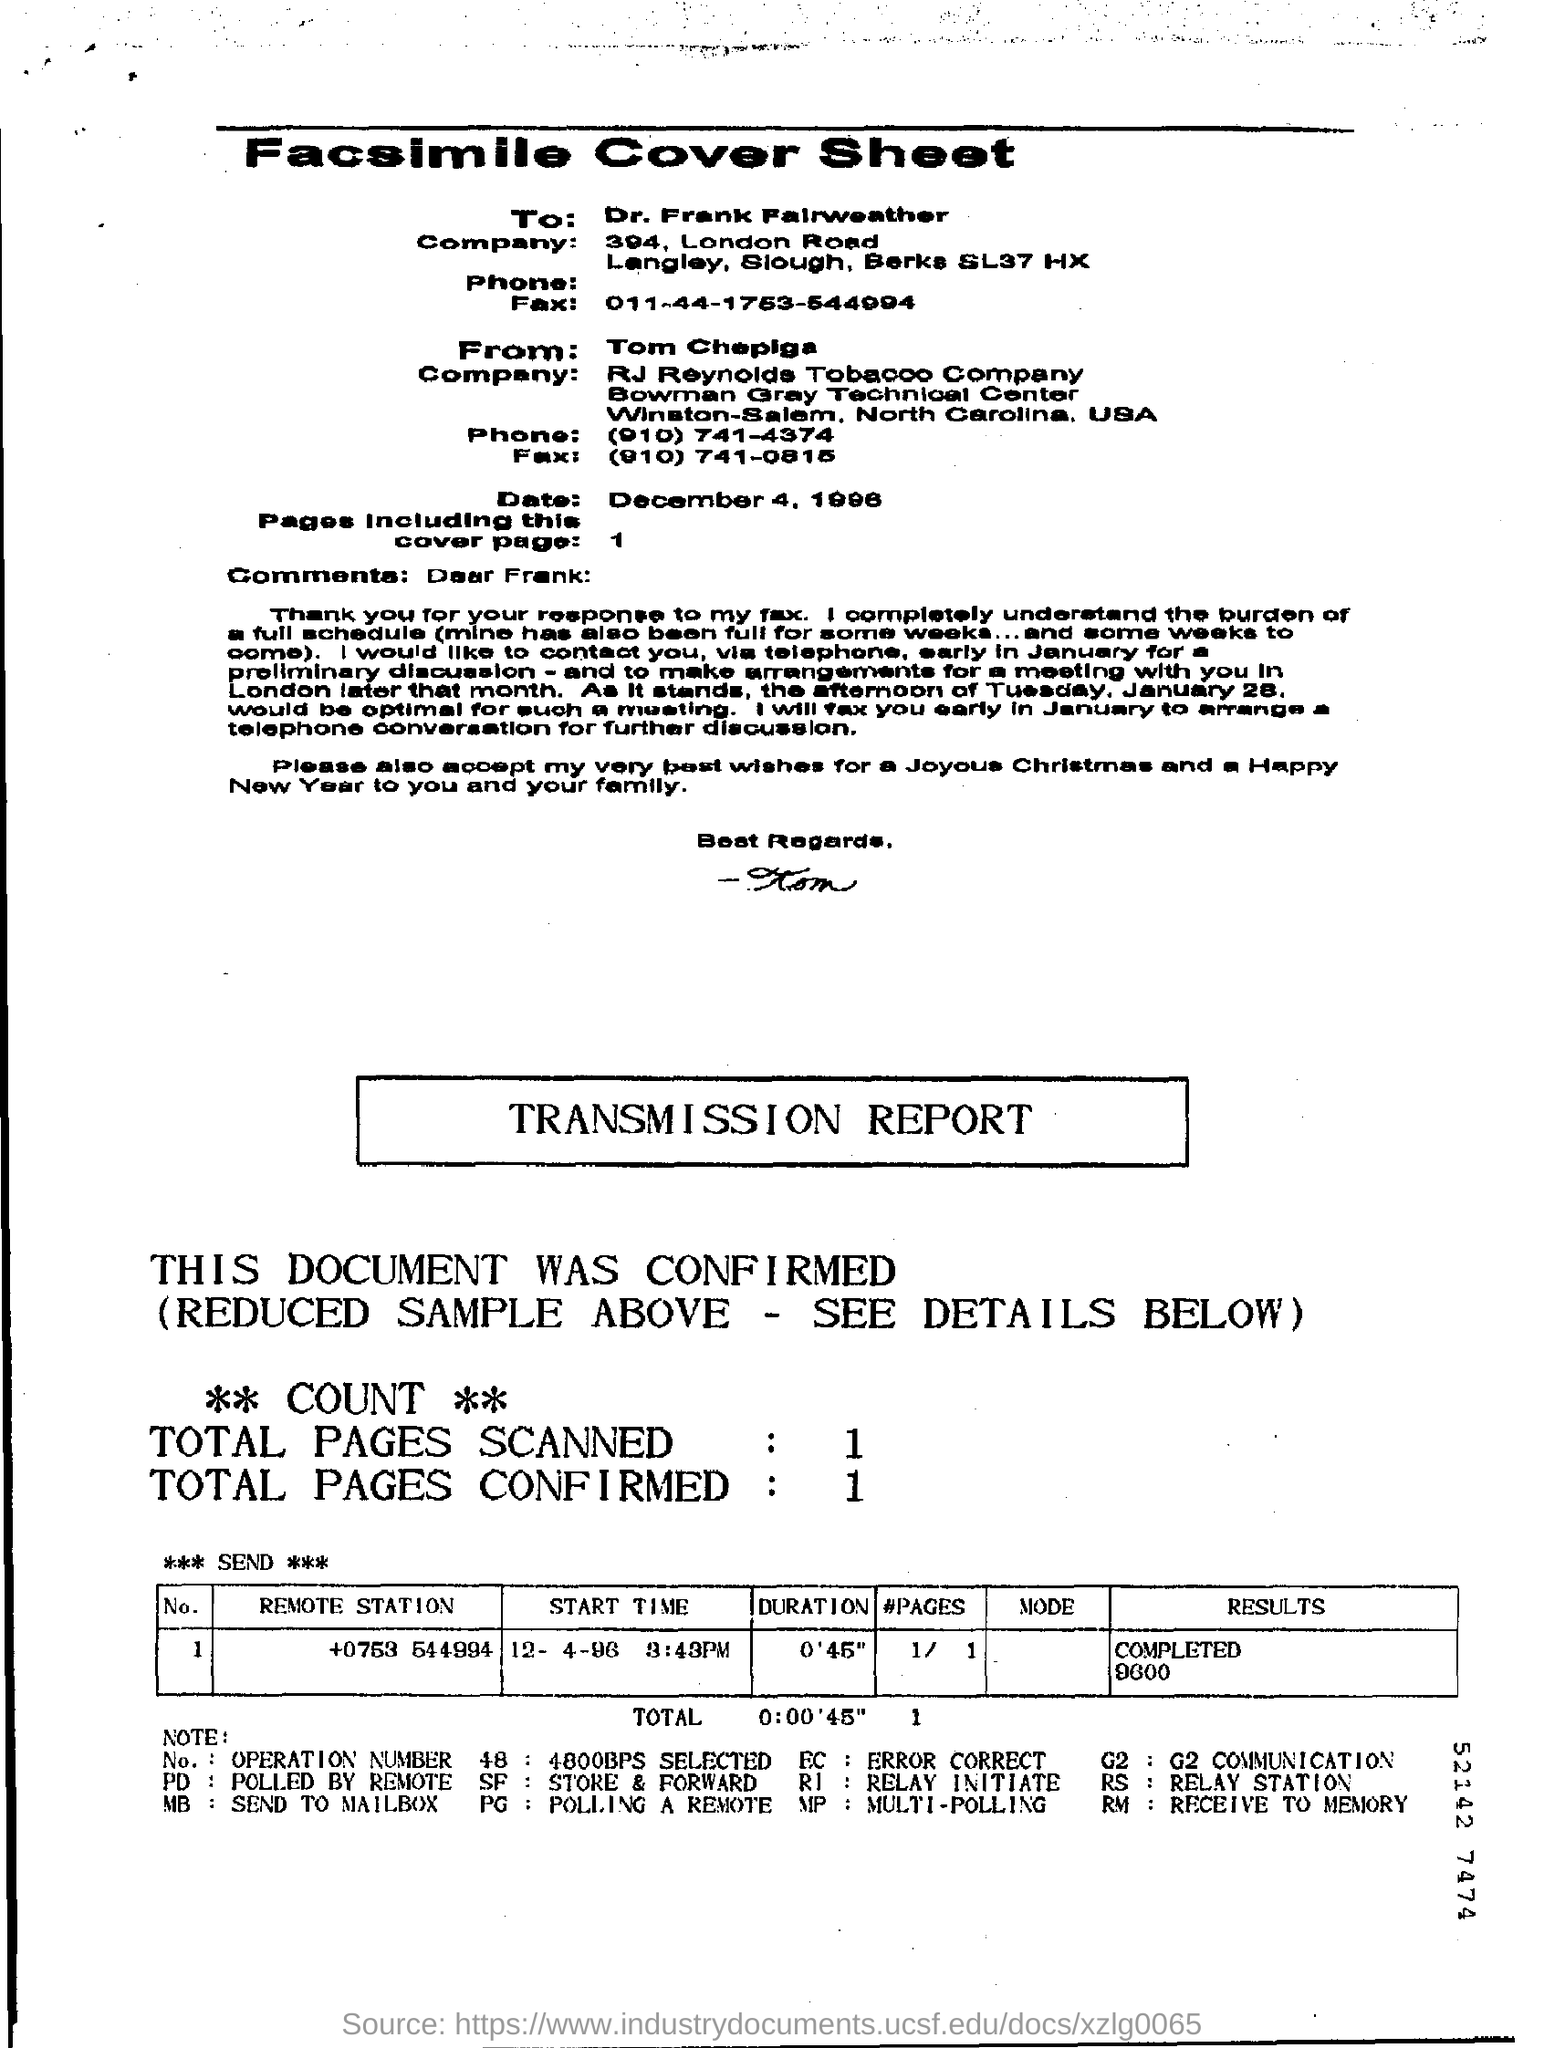To whom is this fax addressed to?
Keep it short and to the point. Dr. Frank Fairweather. What is the Date?
Offer a very short reply. December 4, 1996. 